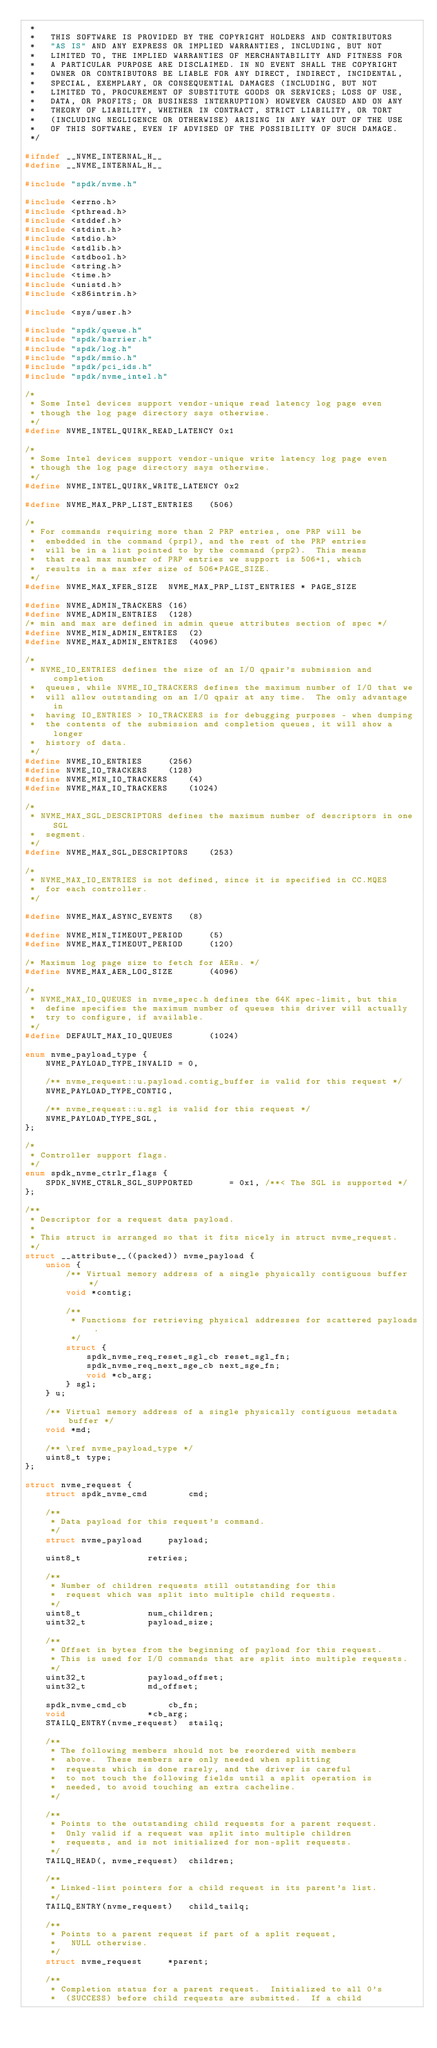<code> <loc_0><loc_0><loc_500><loc_500><_C_> *
 *   THIS SOFTWARE IS PROVIDED BY THE COPYRIGHT HOLDERS AND CONTRIBUTORS
 *   "AS IS" AND ANY EXPRESS OR IMPLIED WARRANTIES, INCLUDING, BUT NOT
 *   LIMITED TO, THE IMPLIED WARRANTIES OF MERCHANTABILITY AND FITNESS FOR
 *   A PARTICULAR PURPOSE ARE DISCLAIMED. IN NO EVENT SHALL THE COPYRIGHT
 *   OWNER OR CONTRIBUTORS BE LIABLE FOR ANY DIRECT, INDIRECT, INCIDENTAL,
 *   SPECIAL, EXEMPLARY, OR CONSEQUENTIAL DAMAGES (INCLUDING, BUT NOT
 *   LIMITED TO, PROCUREMENT OF SUBSTITUTE GOODS OR SERVICES; LOSS OF USE,
 *   DATA, OR PROFITS; OR BUSINESS INTERRUPTION) HOWEVER CAUSED AND ON ANY
 *   THEORY OF LIABILITY, WHETHER IN CONTRACT, STRICT LIABILITY, OR TORT
 *   (INCLUDING NEGLIGENCE OR OTHERWISE) ARISING IN ANY WAY OUT OF THE USE
 *   OF THIS SOFTWARE, EVEN IF ADVISED OF THE POSSIBILITY OF SUCH DAMAGE.
 */

#ifndef __NVME_INTERNAL_H__
#define __NVME_INTERNAL_H__

#include "spdk/nvme.h"

#include <errno.h>
#include <pthread.h>
#include <stddef.h>
#include <stdint.h>
#include <stdio.h>
#include <stdlib.h>
#include <stdbool.h>
#include <string.h>
#include <time.h>
#include <unistd.h>
#include <x86intrin.h>

#include <sys/user.h>

#include "spdk/queue.h"
#include "spdk/barrier.h"
#include "spdk/log.h"
#include "spdk/mmio.h"
#include "spdk/pci_ids.h"
#include "spdk/nvme_intel.h"

/*
 * Some Intel devices support vendor-unique read latency log page even
 * though the log page directory says otherwise.
 */
#define NVME_INTEL_QUIRK_READ_LATENCY 0x1

/*
 * Some Intel devices support vendor-unique write latency log page even
 * though the log page directory says otherwise.
 */
#define NVME_INTEL_QUIRK_WRITE_LATENCY 0x2

#define NVME_MAX_PRP_LIST_ENTRIES	(506)

/*
 * For commands requiring more than 2 PRP entries, one PRP will be
 *  embedded in the command (prp1), and the rest of the PRP entries
 *  will be in a list pointed to by the command (prp2).  This means
 *  that real max number of PRP entries we support is 506+1, which
 *  results in a max xfer size of 506*PAGE_SIZE.
 */
#define NVME_MAX_XFER_SIZE	NVME_MAX_PRP_LIST_ENTRIES * PAGE_SIZE

#define NVME_ADMIN_TRACKERS	(16)
#define NVME_ADMIN_ENTRIES	(128)
/* min and max are defined in admin queue attributes section of spec */
#define NVME_MIN_ADMIN_ENTRIES	(2)
#define NVME_MAX_ADMIN_ENTRIES	(4096)

/*
 * NVME_IO_ENTRIES defines the size of an I/O qpair's submission and completion
 *  queues, while NVME_IO_TRACKERS defines the maximum number of I/O that we
 *  will allow outstanding on an I/O qpair at any time.  The only advantage in
 *  having IO_ENTRIES > IO_TRACKERS is for debugging purposes - when dumping
 *  the contents of the submission and completion queues, it will show a longer
 *  history of data.
 */
#define NVME_IO_ENTRIES		(256)
#define NVME_IO_TRACKERS	(128)
#define NVME_MIN_IO_TRACKERS	(4)
#define NVME_MAX_IO_TRACKERS	(1024)

/*
 * NVME_MAX_SGL_DESCRIPTORS defines the maximum number of descriptors in one SGL
 *  segment.
 */
#define NVME_MAX_SGL_DESCRIPTORS	(253)

/*
 * NVME_MAX_IO_ENTRIES is not defined, since it is specified in CC.MQES
 *  for each controller.
 */

#define NVME_MAX_ASYNC_EVENTS	(8)

#define NVME_MIN_TIMEOUT_PERIOD		(5)
#define NVME_MAX_TIMEOUT_PERIOD		(120)

/* Maximum log page size to fetch for AERs. */
#define NVME_MAX_AER_LOG_SIZE		(4096)

/*
 * NVME_MAX_IO_QUEUES in nvme_spec.h defines the 64K spec-limit, but this
 *  define specifies the maximum number of queues this driver will actually
 *  try to configure, if available.
 */
#define DEFAULT_MAX_IO_QUEUES		(1024)

enum nvme_payload_type {
	NVME_PAYLOAD_TYPE_INVALID = 0,

	/** nvme_request::u.payload.contig_buffer is valid for this request */
	NVME_PAYLOAD_TYPE_CONTIG,

	/** nvme_request::u.sgl is valid for this request */
	NVME_PAYLOAD_TYPE_SGL,
};

/*
 * Controller support flags.
 */
enum spdk_nvme_ctrlr_flags {
	SPDK_NVME_CTRLR_SGL_SUPPORTED		= 0x1, /**< The SGL is supported */
};

/**
 * Descriptor for a request data payload.
 *
 * This struct is arranged so that it fits nicely in struct nvme_request.
 */
struct __attribute__((packed)) nvme_payload {
	union {
		/** Virtual memory address of a single physically contiguous buffer */
		void *contig;

		/**
		 * Functions for retrieving physical addresses for scattered payloads.
		 */
		struct {
			spdk_nvme_req_reset_sgl_cb reset_sgl_fn;
			spdk_nvme_req_next_sge_cb next_sge_fn;
			void *cb_arg;
		} sgl;
	} u;

	/** Virtual memory address of a single physically contiguous metadata buffer */
	void *md;

	/** \ref nvme_payload_type */
	uint8_t type;
};

struct nvme_request {
	struct spdk_nvme_cmd		cmd;

	/**
	 * Data payload for this request's command.
	 */
	struct nvme_payload		payload;

	uint8_t				retries;

	/**
	 * Number of children requests still outstanding for this
	 *  request which was split into multiple child requests.
	 */
	uint8_t				num_children;
	uint32_t			payload_size;

	/**
	 * Offset in bytes from the beginning of payload for this request.
	 * This is used for I/O commands that are split into multiple requests.
	 */
	uint32_t			payload_offset;
	uint32_t			md_offset;

	spdk_nvme_cmd_cb		cb_fn;
	void				*cb_arg;
	STAILQ_ENTRY(nvme_request)	stailq;

	/**
	 * The following members should not be reordered with members
	 *  above.  These members are only needed when splitting
	 *  requests which is done rarely, and the driver is careful
	 *  to not touch the following fields until a split operation is
	 *  needed, to avoid touching an extra cacheline.
	 */

	/**
	 * Points to the outstanding child requests for a parent request.
	 *  Only valid if a request was split into multiple children
	 *  requests, and is not initialized for non-split requests.
	 */
	TAILQ_HEAD(, nvme_request)	children;

	/**
	 * Linked-list pointers for a child request in its parent's list.
	 */
	TAILQ_ENTRY(nvme_request)	child_tailq;

	/**
	 * Points to a parent request if part of a split request,
	 *   NULL otherwise.
	 */
	struct nvme_request		*parent;

	/**
	 * Completion status for a parent request.  Initialized to all 0's
	 *  (SUCCESS) before child requests are submitted.  If a child</code> 